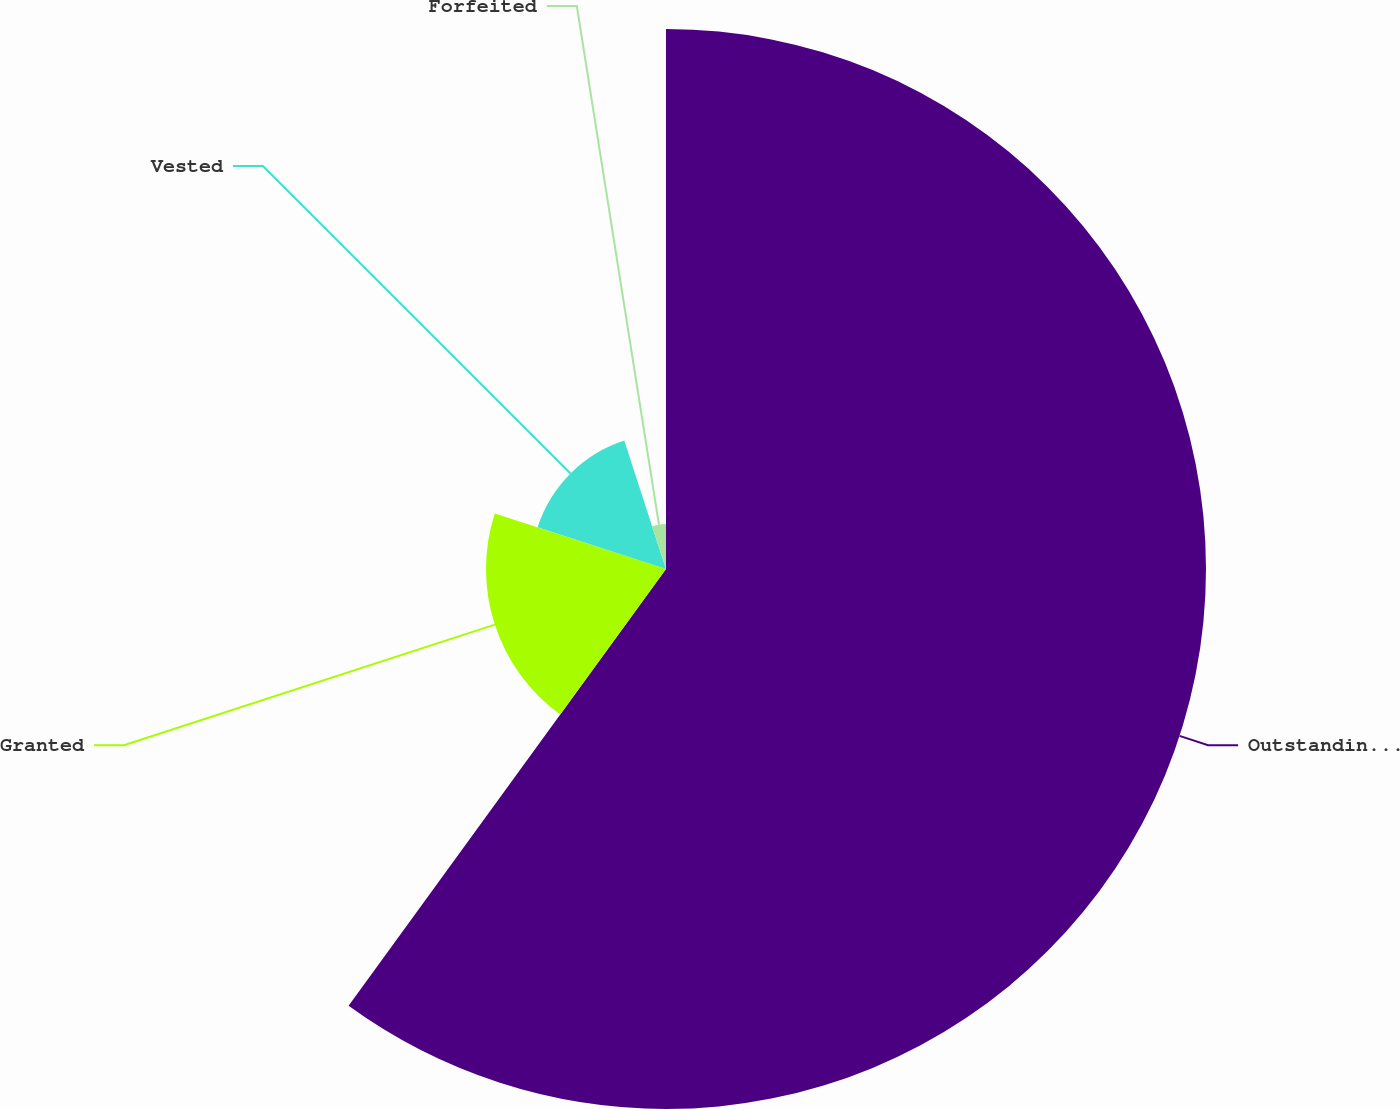<chart> <loc_0><loc_0><loc_500><loc_500><pie_chart><fcel>Outstanding at December 31<fcel>Granted<fcel>Vested<fcel>Forfeited<nl><fcel>60.0%<fcel>20.0%<fcel>15.0%<fcel>5.0%<nl></chart> 